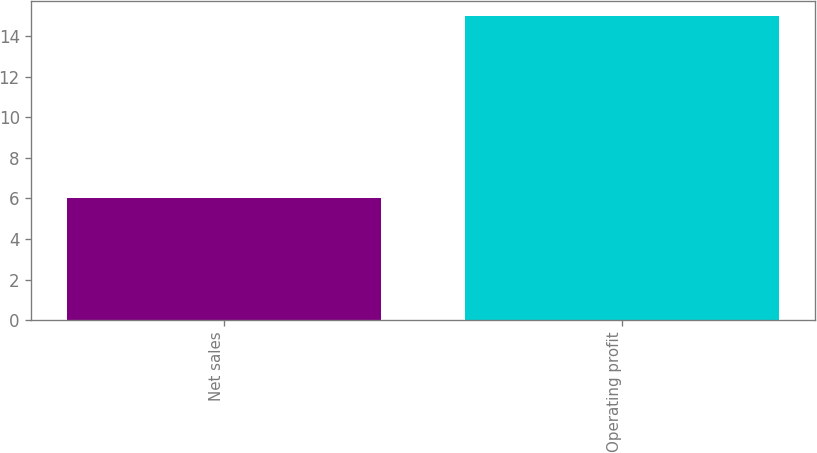Convert chart to OTSL. <chart><loc_0><loc_0><loc_500><loc_500><bar_chart><fcel>Net sales<fcel>Operating profit<nl><fcel>6<fcel>15<nl></chart> 